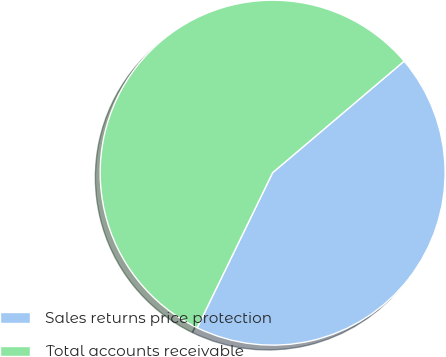Convert chart to OTSL. <chart><loc_0><loc_0><loc_500><loc_500><pie_chart><fcel>Sales returns price protection<fcel>Total accounts receivable<nl><fcel>43.4%<fcel>56.6%<nl></chart> 